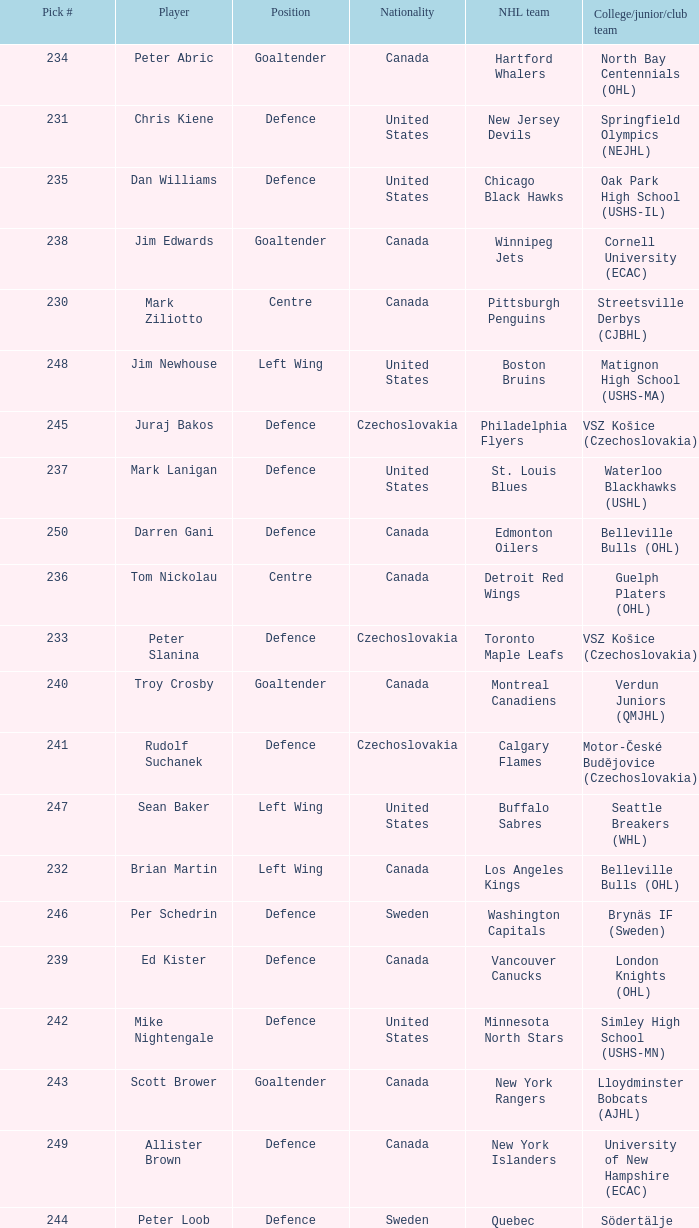To which organziation does the  winnipeg jets belong to? Cornell University (ECAC). 